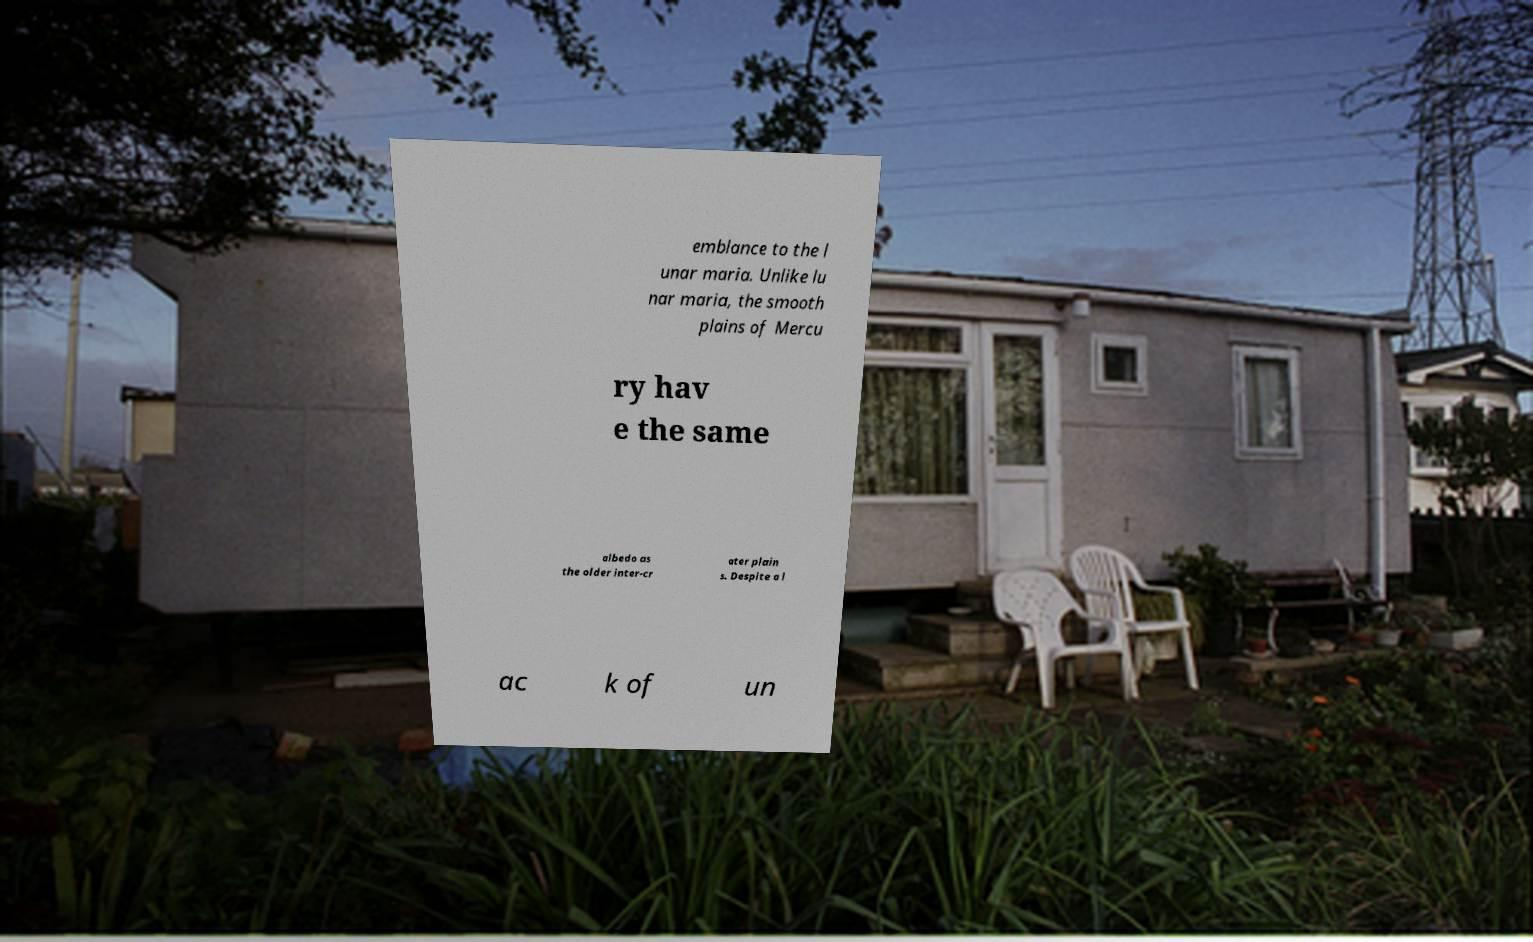Please identify and transcribe the text found in this image. emblance to the l unar maria. Unlike lu nar maria, the smooth plains of Mercu ry hav e the same albedo as the older inter-cr ater plain s. Despite a l ac k of un 